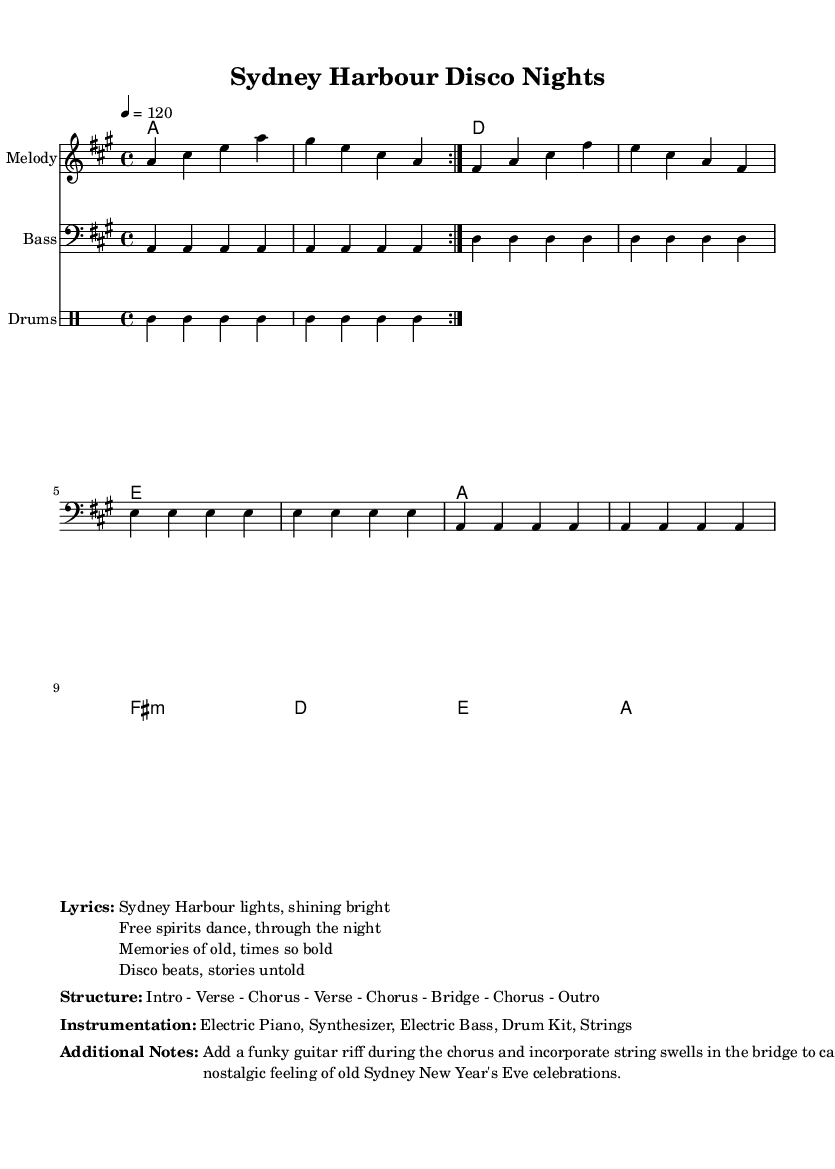What is the key signature of this music? The key signature is A major, which has three sharps: F#, C#, and G#. This can be determined by looking at the key signature symbol at the beginning of the music.
Answer: A major What is the time signature of this piece? The time signature is 4/4, which indicates that there are four beats in each measure and the quarter note gets one beat. This is noted at the beginning of the score next to the key signature.
Answer: 4/4 What is the tempo marking for the music? The tempo marking indicates a speed of 120 beats per minute, which is written as "4 = 120" in the score. This tells how fast the music should be played.
Answer: 120 How many instruments are indicated in the instrumentation? There are five instruments listed: Electric Piano, Synthesizer, Electric Bass, Drum Kit, and Strings. This information can be found under the instrumentation section of the score.
Answer: five What is the structure of the piece? The structure is outlined as Intro - Verse - Chorus - Verse - Chorus - Bridge - Chorus - Outro. This information is presented in a clear format under the structure section of the music sheet.
Answer: Intro - Verse - Chorus - Verse - Chorus - Bridge - Chorus - Outro What kind of additional musical element is suggested for the chorus? A funky guitar riff is suggested to be added during the chorus. This is mentioned in the additional notes section, which provides insight into how the composition can be enhanced for the retro feel.
Answer: funky guitar riff What feeling is captured in this piece according to the additional notes? The additional notes suggest incorporating string swells in the bridge to capture a nostalgic feeling related to the old Sydney New Year's Eve celebrations. This gives a context to the emotional tone intended for this piece.
Answer: nostalgic feeling 